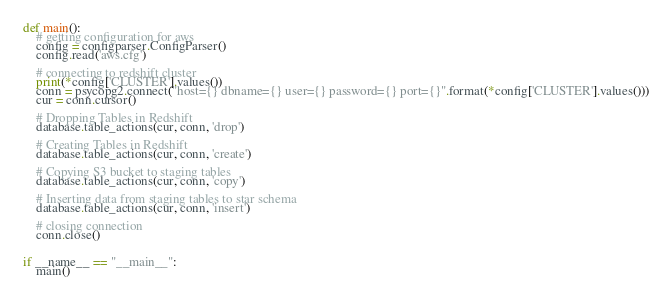Convert code to text. <code><loc_0><loc_0><loc_500><loc_500><_Python_>

def main():
    # getting configuration for aws
    config = configparser.ConfigParser()
    config.read('aws.cfg')

    # connecting to redshift cluster
    print(*config['CLUSTER'].values())
    conn = psycopg2.connect("host={} dbname={} user={} password={} port={}".format(*config['CLUSTER'].values()))
    cur = conn.cursor()

    # Dropping Tables in Redshift
    database.table_actions(cur, conn, 'drop')

    # Creating Tables in Redshift
    database.table_actions(cur, conn, 'create')

    # Copying S3 bucket to staging tables
    database.table_actions(cur, conn, 'copy')

    # Inserting data from staging tables to star schema
    database.table_actions(cur, conn, 'insert')

    # closing connection
    conn.close()


if __name__ == "__main__":
    main()
</code> 